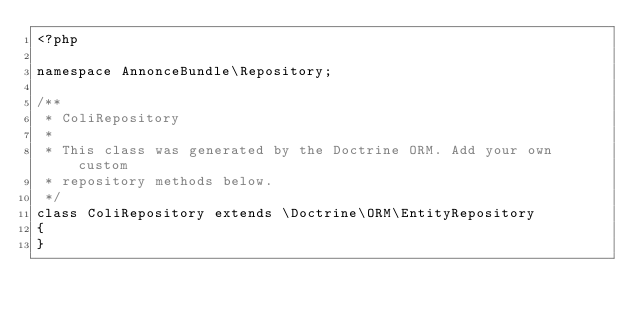Convert code to text. <code><loc_0><loc_0><loc_500><loc_500><_PHP_><?php

namespace AnnonceBundle\Repository;

/**
 * ColiRepository
 *
 * This class was generated by the Doctrine ORM. Add your own custom
 * repository methods below.
 */
class ColiRepository extends \Doctrine\ORM\EntityRepository
{
}
</code> 